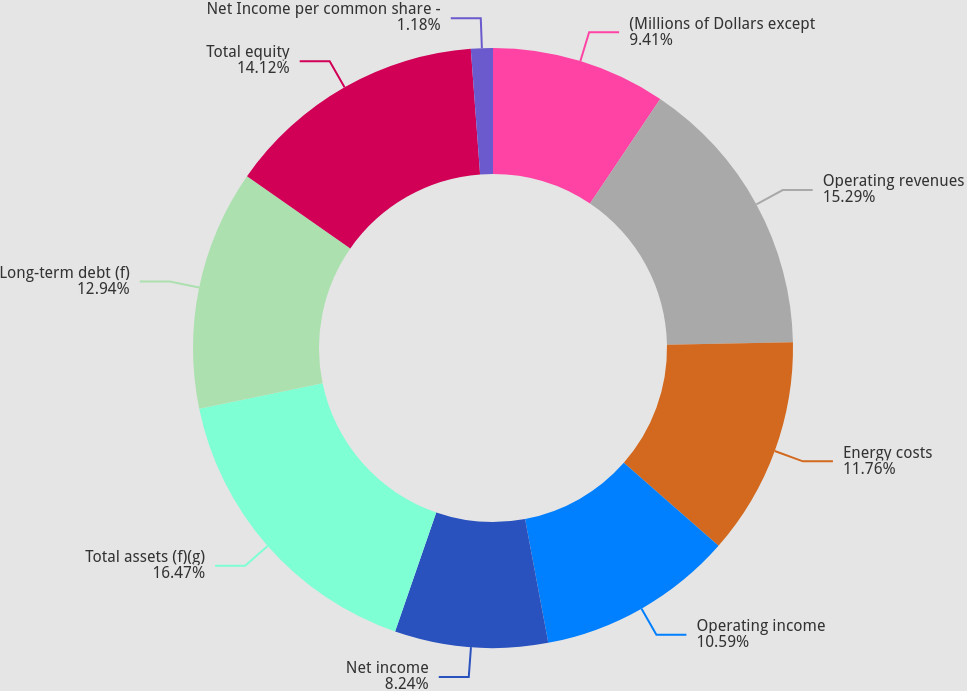Convert chart. <chart><loc_0><loc_0><loc_500><loc_500><pie_chart><fcel>(Millions of Dollars except<fcel>Operating revenues<fcel>Energy costs<fcel>Operating income<fcel>Net income<fcel>Total assets (f)(g)<fcel>Long-term debt (f)<fcel>Total equity<fcel>Net Income per common share -<nl><fcel>9.41%<fcel>15.29%<fcel>11.76%<fcel>10.59%<fcel>8.24%<fcel>16.47%<fcel>12.94%<fcel>14.12%<fcel>1.18%<nl></chart> 